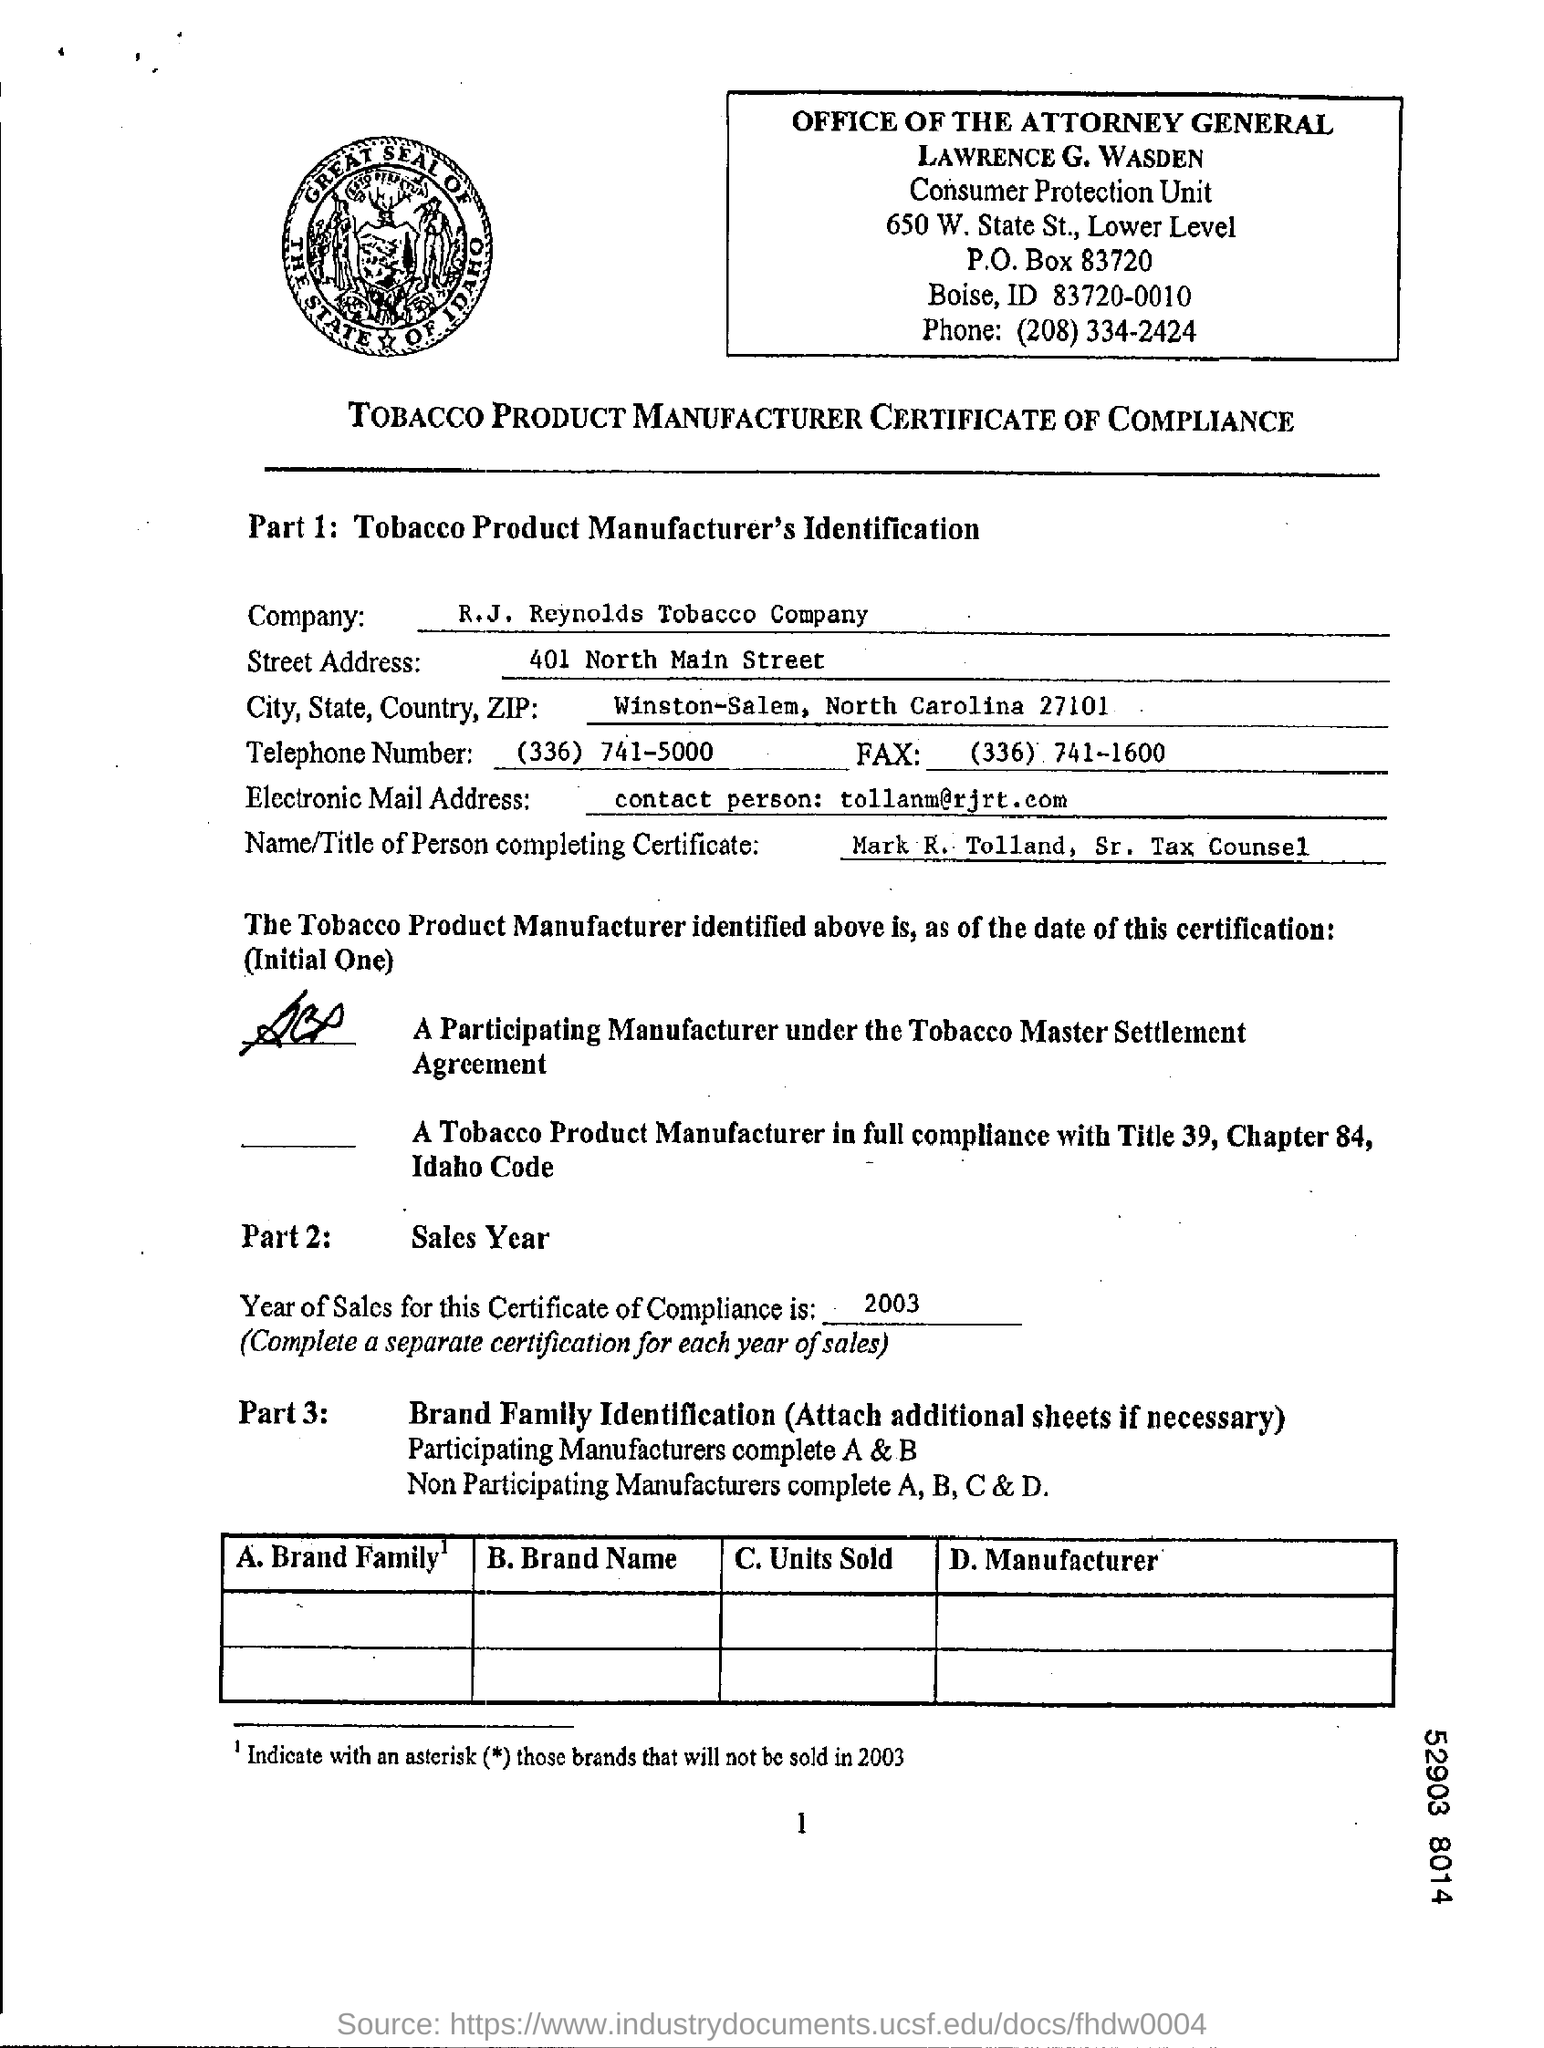What is the Company Name ?
Your response must be concise. R.J. Reynolds Tobacco Company. What is the Fax Number ?
Offer a very short reply. (336) 741-1600. What is the Telephone Number ?
Make the answer very short. (336) 741-5000. What is Written in Electronic Mail Address Field ?
Make the answer very short. Contact person: tollanm@rjrt.com. What is written in Street Address Field ?
Provide a succinct answer. 401 North Main Street. 